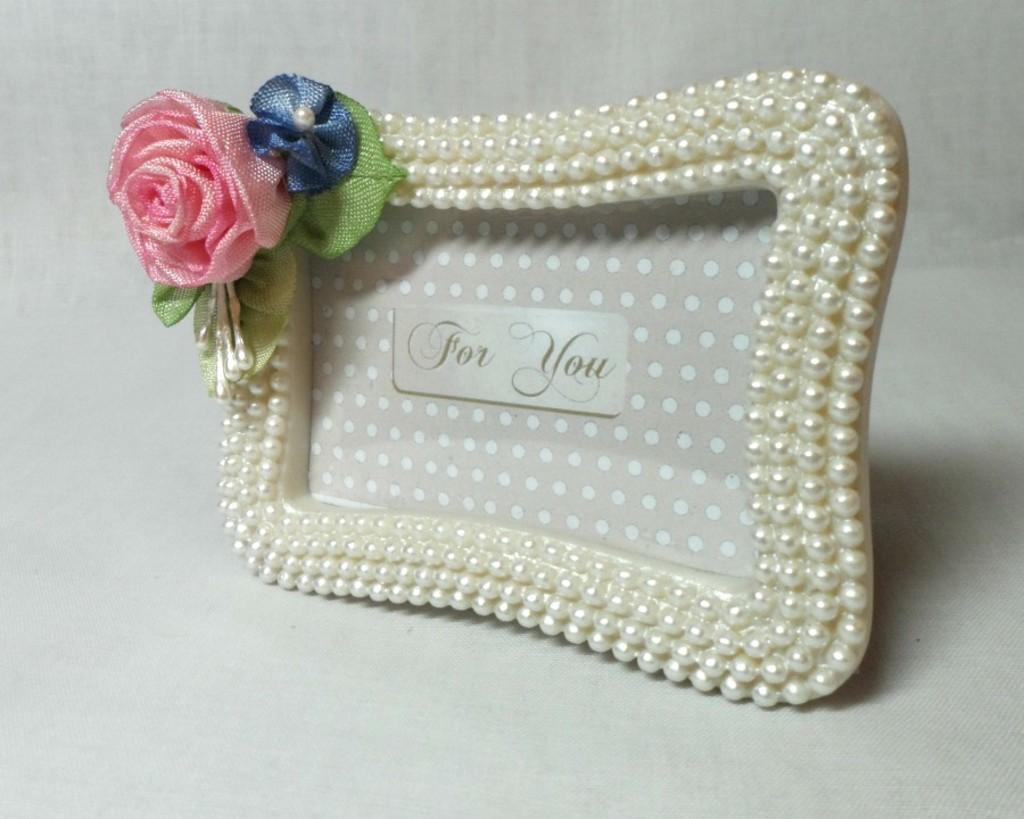Describe this image in one or two sentences. In the picture we can see an album frame with pearls and in its written as for you and on the top of it, we can see an artificial flower which is pink in color and a leaf and other flower which is blue in color. 